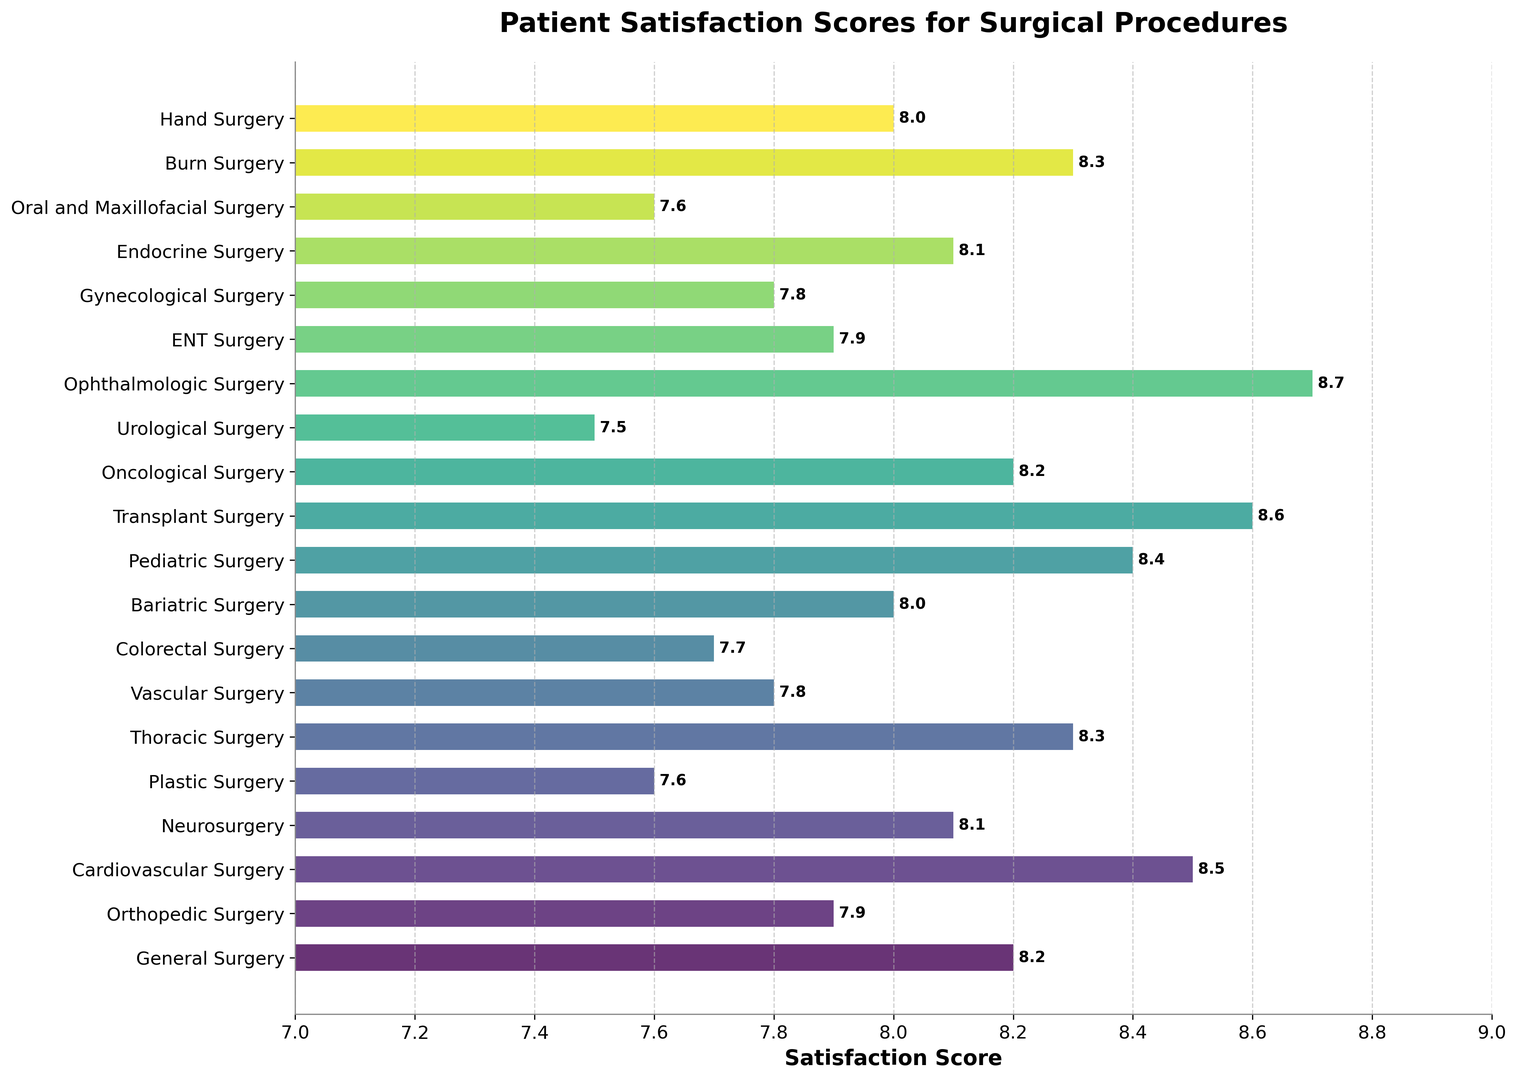What's the procedure with the highest patient satisfaction score? The procedure with the highest bar on the chart is the one with the highest score. Ophthalmologic Surgery has the highest bar.
Answer: Ophthalmologic Surgery Which procedures have scores higher than 8.2? The bars representing scores higher than 8.2 are for procedures with scores greater than 8.2. Cardiovascular Surgery, Thoracic Surgery, Pediatric Surgery, Transplant Surgery, and Ophthalmologic Surgery have scores higher than 8.2.
Answer: Cardiovascular Surgery, Thoracic Surgery, Pediatric Surgery, Transplant Surgery, Ophthalmologic Surgery What is the average satisfaction score of General Surgery, Neurosurgery, and Oncological Surgery combined? Add the scores of General Surgery (8.2), Neurosurgery (8.1), and Oncological Surgery (8.2) and then divide by 3. (8.2 + 8.1 + 8.2) / 3 = 8.17
Answer: 8.17 Which procedure has a lower satisfaction score: Colorectal Surgery or Burn Surgery? Compare the heights of the bars for Colorectal Surgery and Burn Surgery. Colorectal Surgery has a score of 7.7 while Burn Surgery has a score of 8.3.
Answer: Colorectal Surgery What is the score difference between the highest and the lowest satisfaction score? The highest score is for Ophthalmologic Surgery at 8.7, and the lowest is for Urological Surgery at 7.5. The difference is 8.7 - 7.5 = 1.2.
Answer: 1.2 Which procedure has a satisfaction score equal to the score of ENT Surgery? Find the procedure with a bar of the same height as the ENT Surgery bar. Orthopedic Surgery has the same score as ENT Surgery, both at 7.9.
Answer: Orthopedic Surgery What procedures have satisfaction scores between 8.0 and 8.3 inclusive? Identify the bars within the range of 8.0 to 8.3. These procedures are Thoracic Surgery, Burn Surgery (both 8.3), General Surgery, Oncological Surgery (both 8.2), Endocrine Surgery (8.1), Bariatric Surgery, Hand Surgery (both 8.0).
Answer: Thoracic Surgery, Burn Surgery, General Surgery, Oncological Surgery, Endocrine Surgery, Bariatric Surgery, Hand Surgery How many procedures have satisfaction scores below 8.0? Count the number of bars with scores less than 8.0. These procedures are Orthopedic Surgery, Plastic Surgery, Vascular Surgery, Colorectal Surgery, Urological Surgery, Oral and Maxillofacial Surgery, and Gynecological Surgery.
Answer: 7 What is the median satisfaction score? List the scores in ascending order and find the middle value. The median of 20 scores is the average of the 10th and 11th scores in the sorted list: (8.0 + 8.0) / 2 = 8.0.
Answer: 8.0 